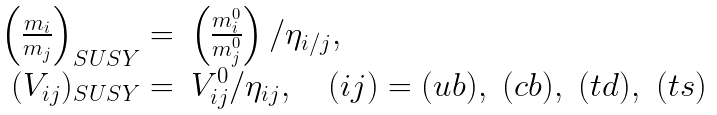<formula> <loc_0><loc_0><loc_500><loc_500>\begin{array} { r l } { { \left ( \frac { m _ { i } } { m _ { j } } \right ) _ { S U S Y } = } } & { { \left ( \frac { m _ { i } ^ { 0 } } { m _ { j } ^ { 0 } } \right ) / \eta _ { i / j } , } } \\ { { ( V _ { i j } ) _ { S U S Y } = } } & { { V _ { i j } ^ { 0 } / \eta _ { i j } , \quad ( i j ) = ( u b ) , \ ( c b ) , \ ( t d ) , \ ( t s ) } } \end{array}</formula> 